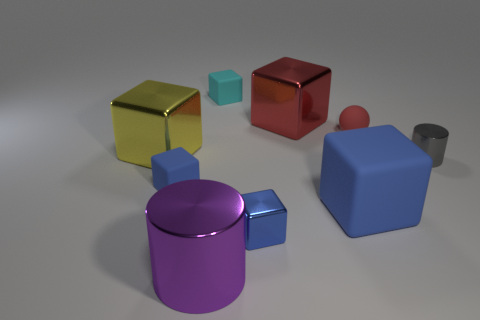Subtract all red balls. How many blue blocks are left? 3 Subtract 2 cubes. How many cubes are left? 4 Subtract all red blocks. How many blocks are left? 5 Subtract all yellow metal cubes. How many cubes are left? 5 Subtract all red cubes. Subtract all red cylinders. How many cubes are left? 5 Add 1 blue rubber blocks. How many objects exist? 10 Subtract all balls. How many objects are left? 8 Add 5 small blue rubber things. How many small blue rubber things exist? 6 Subtract 1 red spheres. How many objects are left? 8 Subtract all matte balls. Subtract all tiny shiny objects. How many objects are left? 6 